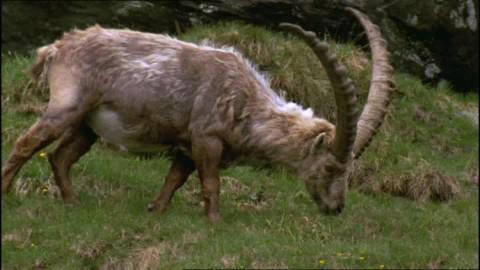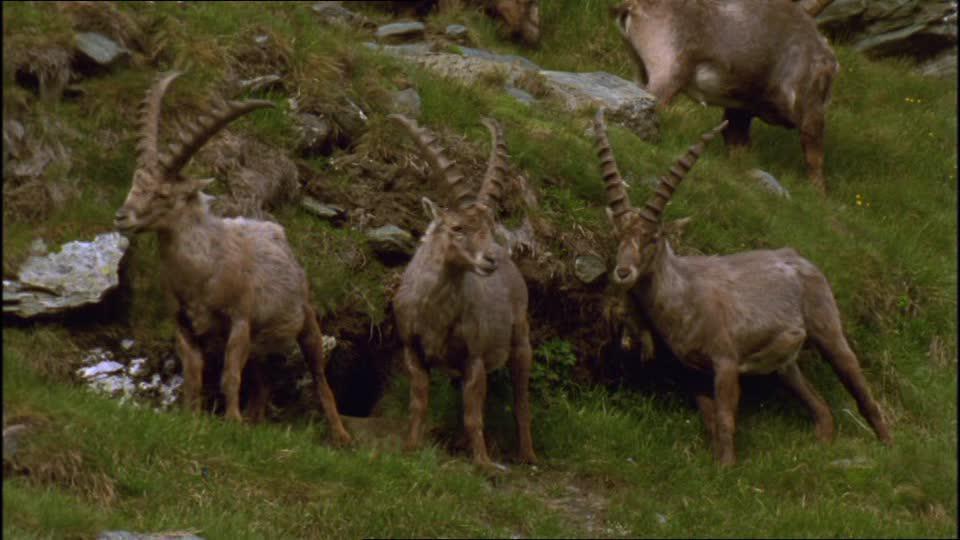The first image is the image on the left, the second image is the image on the right. For the images shown, is this caption "A single animal is standing in the grass in the image on the left." true? Answer yes or no. Yes. The first image is the image on the left, the second image is the image on the right. Evaluate the accuracy of this statement regarding the images: "An image contains only a rightward-facing horned animal in a pose on green grass.". Is it true? Answer yes or no. Yes. 